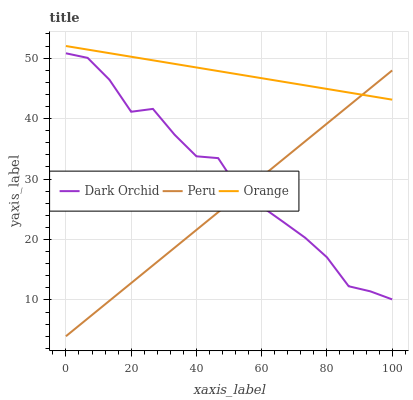Does Dark Orchid have the minimum area under the curve?
Answer yes or no. No. Does Dark Orchid have the maximum area under the curve?
Answer yes or no. No. Is Dark Orchid the smoothest?
Answer yes or no. No. Is Peru the roughest?
Answer yes or no. No. Does Dark Orchid have the lowest value?
Answer yes or no. No. Does Dark Orchid have the highest value?
Answer yes or no. No. Is Dark Orchid less than Orange?
Answer yes or no. Yes. Is Orange greater than Dark Orchid?
Answer yes or no. Yes. Does Dark Orchid intersect Orange?
Answer yes or no. No. 